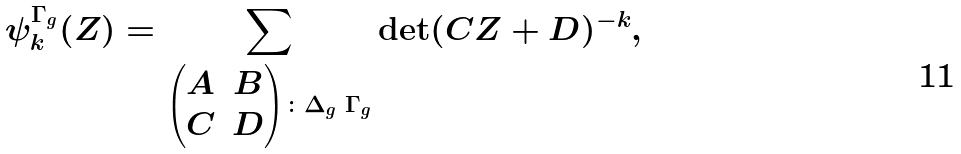Convert formula to latex. <formula><loc_0><loc_0><loc_500><loc_500>\psi _ { k } ^ { \Gamma _ { g } } ( Z ) = \sum _ { \begin{pmatrix} A & B \\ C & D \end{pmatrix} \colon \Delta _ { g } \ \Gamma _ { g } } \det ( C Z + D ) ^ { - k } ,</formula> 